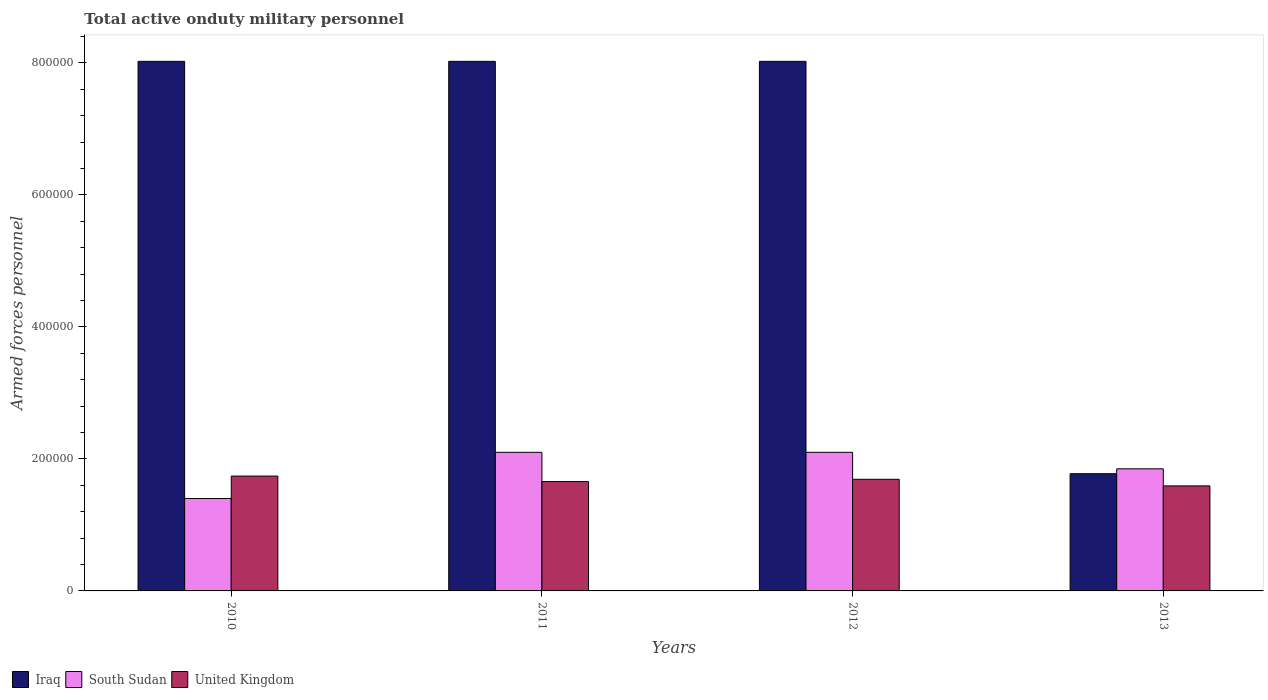Are the number of bars per tick equal to the number of legend labels?
Make the answer very short. Yes. How many bars are there on the 3rd tick from the right?
Keep it short and to the point. 3. What is the label of the 2nd group of bars from the left?
Provide a succinct answer. 2011. What is the number of armed forces personnel in United Kingdom in 2010?
Your answer should be very brief. 1.74e+05. Across all years, what is the maximum number of armed forces personnel in South Sudan?
Give a very brief answer. 2.10e+05. Across all years, what is the minimum number of armed forces personnel in Iraq?
Ensure brevity in your answer.  1.78e+05. In which year was the number of armed forces personnel in Iraq maximum?
Offer a terse response. 2010. What is the total number of armed forces personnel in South Sudan in the graph?
Offer a terse response. 7.45e+05. What is the difference between the number of armed forces personnel in United Kingdom in 2011 and that in 2013?
Give a very brief answer. 6500. What is the difference between the number of armed forces personnel in South Sudan in 2010 and the number of armed forces personnel in United Kingdom in 2013?
Your answer should be compact. -1.92e+04. What is the average number of armed forces personnel in South Sudan per year?
Make the answer very short. 1.86e+05. In the year 2011, what is the difference between the number of armed forces personnel in United Kingdom and number of armed forces personnel in Iraq?
Offer a very short reply. -6.37e+05. What is the ratio of the number of armed forces personnel in Iraq in 2011 to that in 2012?
Your response must be concise. 1. Is the difference between the number of armed forces personnel in United Kingdom in 2010 and 2012 greater than the difference between the number of armed forces personnel in Iraq in 2010 and 2012?
Your response must be concise. Yes. Is the sum of the number of armed forces personnel in Iraq in 2010 and 2011 greater than the maximum number of armed forces personnel in South Sudan across all years?
Offer a very short reply. Yes. What does the 3rd bar from the right in 2013 represents?
Your answer should be compact. Iraq. Is it the case that in every year, the sum of the number of armed forces personnel in Iraq and number of armed forces personnel in South Sudan is greater than the number of armed forces personnel in United Kingdom?
Provide a short and direct response. Yes. Are all the bars in the graph horizontal?
Your response must be concise. No. How many years are there in the graph?
Offer a very short reply. 4. What is the difference between two consecutive major ticks on the Y-axis?
Provide a succinct answer. 2.00e+05. Does the graph contain grids?
Provide a short and direct response. No. How many legend labels are there?
Offer a terse response. 3. What is the title of the graph?
Provide a succinct answer. Total active onduty military personnel. Does "Nigeria" appear as one of the legend labels in the graph?
Your answer should be very brief. No. What is the label or title of the X-axis?
Give a very brief answer. Years. What is the label or title of the Y-axis?
Offer a terse response. Armed forces personnel. What is the Armed forces personnel of Iraq in 2010?
Give a very brief answer. 8.02e+05. What is the Armed forces personnel in South Sudan in 2010?
Your response must be concise. 1.40e+05. What is the Armed forces personnel in United Kingdom in 2010?
Your response must be concise. 1.74e+05. What is the Armed forces personnel of Iraq in 2011?
Make the answer very short. 8.02e+05. What is the Armed forces personnel of United Kingdom in 2011?
Offer a very short reply. 1.66e+05. What is the Armed forces personnel of Iraq in 2012?
Keep it short and to the point. 8.02e+05. What is the Armed forces personnel of South Sudan in 2012?
Provide a short and direct response. 2.10e+05. What is the Armed forces personnel of United Kingdom in 2012?
Give a very brief answer. 1.69e+05. What is the Armed forces personnel of Iraq in 2013?
Your response must be concise. 1.78e+05. What is the Armed forces personnel in South Sudan in 2013?
Offer a very short reply. 1.85e+05. What is the Armed forces personnel in United Kingdom in 2013?
Your answer should be very brief. 1.59e+05. Across all years, what is the maximum Armed forces personnel of Iraq?
Ensure brevity in your answer.  8.02e+05. Across all years, what is the maximum Armed forces personnel in United Kingdom?
Give a very brief answer. 1.74e+05. Across all years, what is the minimum Armed forces personnel in Iraq?
Offer a terse response. 1.78e+05. Across all years, what is the minimum Armed forces personnel in South Sudan?
Your answer should be very brief. 1.40e+05. Across all years, what is the minimum Armed forces personnel in United Kingdom?
Keep it short and to the point. 1.59e+05. What is the total Armed forces personnel of Iraq in the graph?
Your answer should be very brief. 2.58e+06. What is the total Armed forces personnel of South Sudan in the graph?
Provide a short and direct response. 7.45e+05. What is the total Armed forces personnel of United Kingdom in the graph?
Offer a very short reply. 6.68e+05. What is the difference between the Armed forces personnel of South Sudan in 2010 and that in 2011?
Offer a very short reply. -7.00e+04. What is the difference between the Armed forces personnel in United Kingdom in 2010 and that in 2011?
Offer a very short reply. 8370. What is the difference between the Armed forces personnel in United Kingdom in 2010 and that in 2012?
Keep it short and to the point. 4870. What is the difference between the Armed forces personnel in Iraq in 2010 and that in 2013?
Give a very brief answer. 6.25e+05. What is the difference between the Armed forces personnel of South Sudan in 2010 and that in 2013?
Your answer should be compact. -4.50e+04. What is the difference between the Armed forces personnel of United Kingdom in 2010 and that in 2013?
Offer a very short reply. 1.49e+04. What is the difference between the Armed forces personnel in Iraq in 2011 and that in 2012?
Your answer should be compact. 0. What is the difference between the Armed forces personnel of South Sudan in 2011 and that in 2012?
Provide a short and direct response. 0. What is the difference between the Armed forces personnel in United Kingdom in 2011 and that in 2012?
Make the answer very short. -3500. What is the difference between the Armed forces personnel of Iraq in 2011 and that in 2013?
Make the answer very short. 6.25e+05. What is the difference between the Armed forces personnel in South Sudan in 2011 and that in 2013?
Keep it short and to the point. 2.50e+04. What is the difference between the Armed forces personnel in United Kingdom in 2011 and that in 2013?
Keep it short and to the point. 6500. What is the difference between the Armed forces personnel of Iraq in 2012 and that in 2013?
Your answer should be very brief. 6.25e+05. What is the difference between the Armed forces personnel of South Sudan in 2012 and that in 2013?
Ensure brevity in your answer.  2.50e+04. What is the difference between the Armed forces personnel of United Kingdom in 2012 and that in 2013?
Offer a terse response. 10000. What is the difference between the Armed forces personnel of Iraq in 2010 and the Armed forces personnel of South Sudan in 2011?
Give a very brief answer. 5.92e+05. What is the difference between the Armed forces personnel of Iraq in 2010 and the Armed forces personnel of United Kingdom in 2011?
Provide a succinct answer. 6.37e+05. What is the difference between the Armed forces personnel in South Sudan in 2010 and the Armed forces personnel in United Kingdom in 2011?
Your response must be concise. -2.56e+04. What is the difference between the Armed forces personnel of Iraq in 2010 and the Armed forces personnel of South Sudan in 2012?
Offer a very short reply. 5.92e+05. What is the difference between the Armed forces personnel of Iraq in 2010 and the Armed forces personnel of United Kingdom in 2012?
Ensure brevity in your answer.  6.33e+05. What is the difference between the Armed forces personnel of South Sudan in 2010 and the Armed forces personnel of United Kingdom in 2012?
Offer a terse response. -2.92e+04. What is the difference between the Armed forces personnel of Iraq in 2010 and the Armed forces personnel of South Sudan in 2013?
Keep it short and to the point. 6.17e+05. What is the difference between the Armed forces personnel in Iraq in 2010 and the Armed forces personnel in United Kingdom in 2013?
Offer a very short reply. 6.43e+05. What is the difference between the Armed forces personnel in South Sudan in 2010 and the Armed forces personnel in United Kingdom in 2013?
Give a very brief answer. -1.92e+04. What is the difference between the Armed forces personnel in Iraq in 2011 and the Armed forces personnel in South Sudan in 2012?
Ensure brevity in your answer.  5.92e+05. What is the difference between the Armed forces personnel of Iraq in 2011 and the Armed forces personnel of United Kingdom in 2012?
Your response must be concise. 6.33e+05. What is the difference between the Armed forces personnel in South Sudan in 2011 and the Armed forces personnel in United Kingdom in 2012?
Offer a very short reply. 4.08e+04. What is the difference between the Armed forces personnel in Iraq in 2011 and the Armed forces personnel in South Sudan in 2013?
Offer a very short reply. 6.17e+05. What is the difference between the Armed forces personnel of Iraq in 2011 and the Armed forces personnel of United Kingdom in 2013?
Provide a succinct answer. 6.43e+05. What is the difference between the Armed forces personnel in South Sudan in 2011 and the Armed forces personnel in United Kingdom in 2013?
Keep it short and to the point. 5.08e+04. What is the difference between the Armed forces personnel of Iraq in 2012 and the Armed forces personnel of South Sudan in 2013?
Keep it short and to the point. 6.17e+05. What is the difference between the Armed forces personnel in Iraq in 2012 and the Armed forces personnel in United Kingdom in 2013?
Give a very brief answer. 6.43e+05. What is the difference between the Armed forces personnel in South Sudan in 2012 and the Armed forces personnel in United Kingdom in 2013?
Provide a short and direct response. 5.08e+04. What is the average Armed forces personnel of Iraq per year?
Give a very brief answer. 6.46e+05. What is the average Armed forces personnel in South Sudan per year?
Your answer should be very brief. 1.86e+05. What is the average Armed forces personnel in United Kingdom per year?
Provide a short and direct response. 1.67e+05. In the year 2010, what is the difference between the Armed forces personnel in Iraq and Armed forces personnel in South Sudan?
Your answer should be compact. 6.62e+05. In the year 2010, what is the difference between the Armed forces personnel in Iraq and Armed forces personnel in United Kingdom?
Your answer should be compact. 6.28e+05. In the year 2010, what is the difference between the Armed forces personnel in South Sudan and Armed forces personnel in United Kingdom?
Provide a succinct answer. -3.40e+04. In the year 2011, what is the difference between the Armed forces personnel in Iraq and Armed forces personnel in South Sudan?
Provide a succinct answer. 5.92e+05. In the year 2011, what is the difference between the Armed forces personnel in Iraq and Armed forces personnel in United Kingdom?
Offer a terse response. 6.37e+05. In the year 2011, what is the difference between the Armed forces personnel of South Sudan and Armed forces personnel of United Kingdom?
Keep it short and to the point. 4.44e+04. In the year 2012, what is the difference between the Armed forces personnel in Iraq and Armed forces personnel in South Sudan?
Keep it short and to the point. 5.92e+05. In the year 2012, what is the difference between the Armed forces personnel of Iraq and Armed forces personnel of United Kingdom?
Provide a short and direct response. 6.33e+05. In the year 2012, what is the difference between the Armed forces personnel in South Sudan and Armed forces personnel in United Kingdom?
Offer a terse response. 4.08e+04. In the year 2013, what is the difference between the Armed forces personnel in Iraq and Armed forces personnel in South Sudan?
Provide a succinct answer. -7400. In the year 2013, what is the difference between the Armed forces personnel of Iraq and Armed forces personnel of United Kingdom?
Offer a terse response. 1.84e+04. In the year 2013, what is the difference between the Armed forces personnel of South Sudan and Armed forces personnel of United Kingdom?
Make the answer very short. 2.58e+04. What is the ratio of the Armed forces personnel in United Kingdom in 2010 to that in 2011?
Your answer should be very brief. 1.05. What is the ratio of the Armed forces personnel in Iraq in 2010 to that in 2012?
Give a very brief answer. 1. What is the ratio of the Armed forces personnel of United Kingdom in 2010 to that in 2012?
Offer a terse response. 1.03. What is the ratio of the Armed forces personnel of Iraq in 2010 to that in 2013?
Make the answer very short. 4.52. What is the ratio of the Armed forces personnel of South Sudan in 2010 to that in 2013?
Ensure brevity in your answer.  0.76. What is the ratio of the Armed forces personnel of United Kingdom in 2010 to that in 2013?
Make the answer very short. 1.09. What is the ratio of the Armed forces personnel of Iraq in 2011 to that in 2012?
Your answer should be very brief. 1. What is the ratio of the Armed forces personnel of United Kingdom in 2011 to that in 2012?
Your response must be concise. 0.98. What is the ratio of the Armed forces personnel of Iraq in 2011 to that in 2013?
Your answer should be very brief. 4.52. What is the ratio of the Armed forces personnel of South Sudan in 2011 to that in 2013?
Make the answer very short. 1.14. What is the ratio of the Armed forces personnel of United Kingdom in 2011 to that in 2013?
Your answer should be very brief. 1.04. What is the ratio of the Armed forces personnel in Iraq in 2012 to that in 2013?
Your answer should be very brief. 4.52. What is the ratio of the Armed forces personnel of South Sudan in 2012 to that in 2013?
Make the answer very short. 1.14. What is the ratio of the Armed forces personnel in United Kingdom in 2012 to that in 2013?
Provide a short and direct response. 1.06. What is the difference between the highest and the second highest Armed forces personnel of United Kingdom?
Offer a terse response. 4870. What is the difference between the highest and the lowest Armed forces personnel of Iraq?
Your answer should be very brief. 6.25e+05. What is the difference between the highest and the lowest Armed forces personnel of South Sudan?
Keep it short and to the point. 7.00e+04. What is the difference between the highest and the lowest Armed forces personnel in United Kingdom?
Make the answer very short. 1.49e+04. 